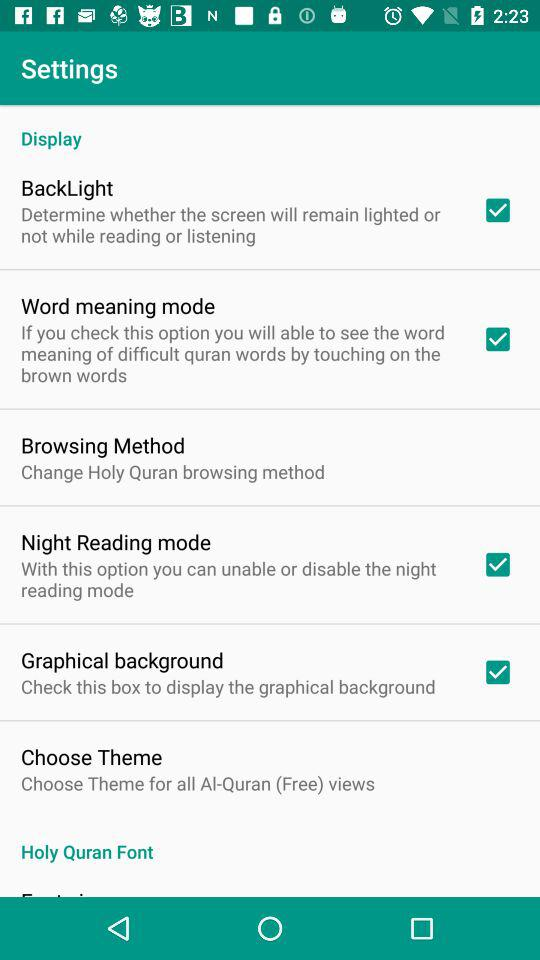Can you describe the interface design of the settings screen? Certainly! The interface has a clean, organized layout with a light color scheme. Each setting is listed under a descriptive heading that explains its purpose. There's a clear visual hierarchy, with primary options using bold type and secondary details in a smaller font. Interaction is facilitated through checkboxes, making it user-friendly and accessible. 